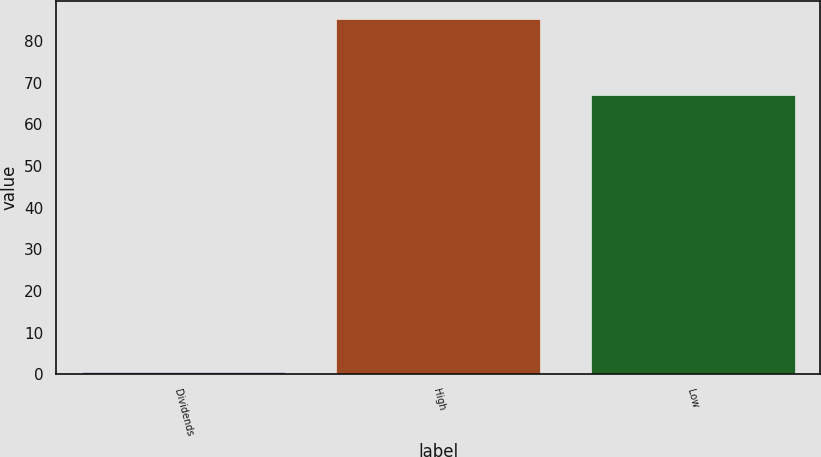Convert chart to OTSL. <chart><loc_0><loc_0><loc_500><loc_500><bar_chart><fcel>Dividends<fcel>High<fcel>Low<nl><fcel>0.55<fcel>85.3<fcel>67.06<nl></chart> 